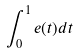<formula> <loc_0><loc_0><loc_500><loc_500>\int _ { 0 } ^ { 1 } e ( t ) d t</formula> 